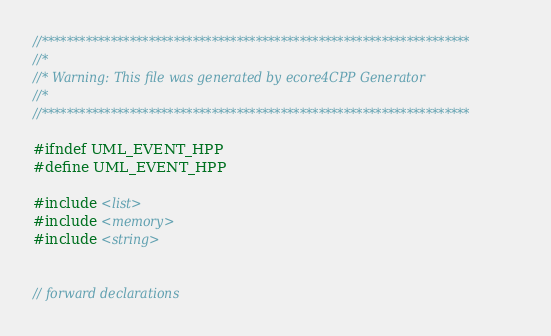<code> <loc_0><loc_0><loc_500><loc_500><_C++_>//********************************************************************
//*    
//* Warning: This file was generated by ecore4CPP Generator
//*
//********************************************************************

#ifndef UML_EVENT_HPP
#define UML_EVENT_HPP

#include <list>
#include <memory>
#include <string>


// forward declarations


</code> 